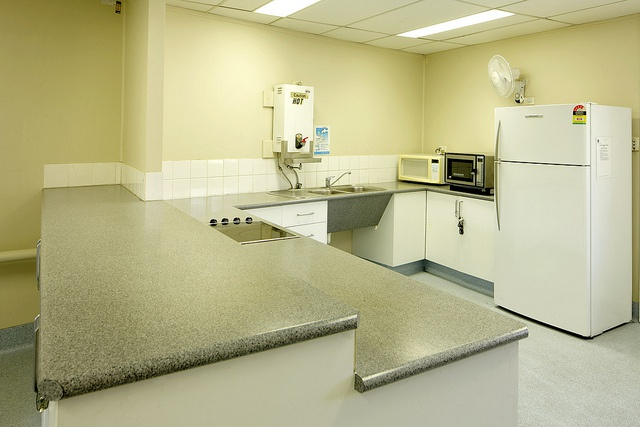Describe the objects in this image and their specific colors. I can see refrigerator in olive, beige, darkgray, and lightgray tones, oven in olive and black tones, microwave in olive, black, and gray tones, oven in olive, black, and gray tones, and microwave in olive, khaki, and tan tones in this image. 